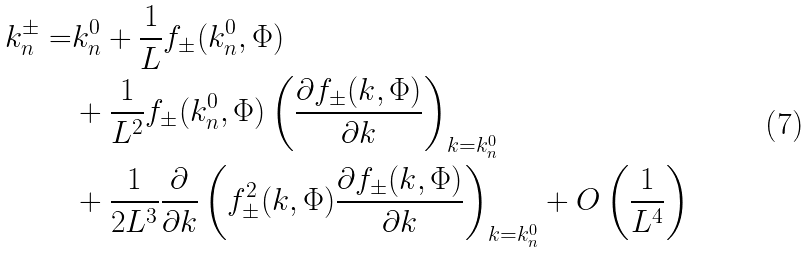<formula> <loc_0><loc_0><loc_500><loc_500>k _ { n } ^ { \pm } = & k ^ { 0 } _ { n } + \frac { 1 } { L } f _ { \pm } ( k ^ { 0 } _ { n } , \Phi ) \\ & + \frac { 1 } { L ^ { 2 } } f _ { \pm } ( k ^ { 0 } _ { n } , \Phi ) \left ( \frac { \partial f _ { \pm } ( k , \Phi ) } { \partial k } \right ) _ { k = k _ { n } ^ { 0 } } \\ & + \frac { 1 } { 2 L ^ { 3 } } \frac { \partial } { \partial k } \left ( f ^ { 2 } _ { \pm } ( k , \Phi ) \frac { \partial f _ { \pm } ( k , \Phi ) } { \partial k } \right ) _ { k = k _ { n } ^ { 0 } } + O \left ( \frac { 1 } { L ^ { 4 } } \right )</formula> 